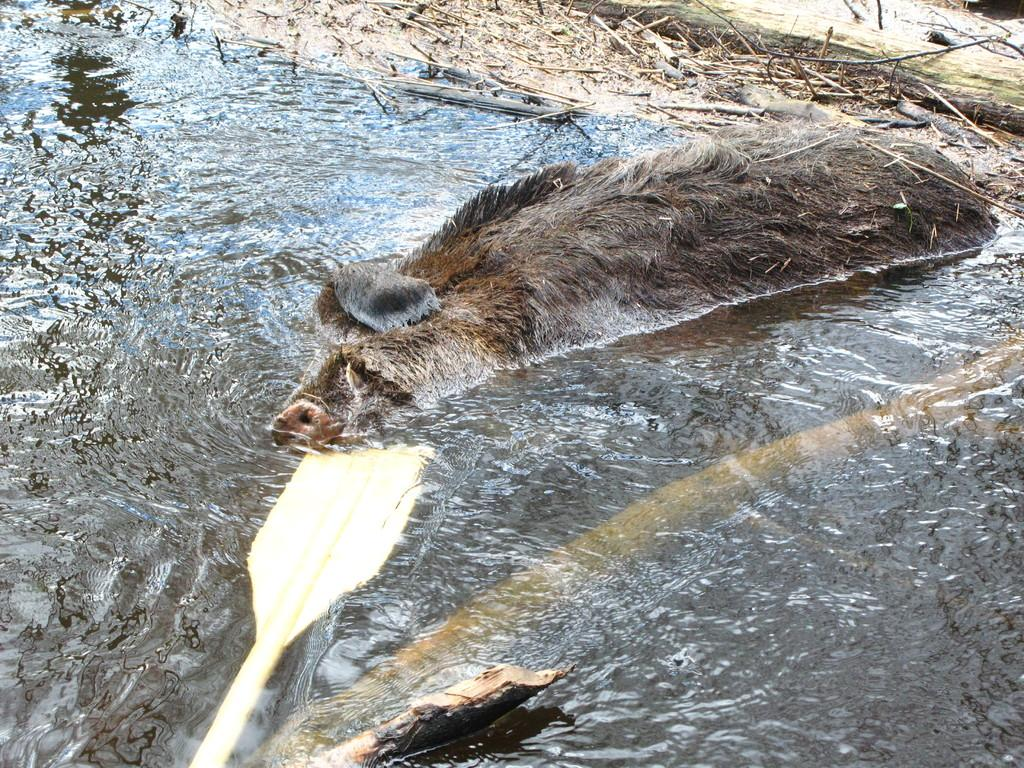What type of animal is present in the image? There is an animal in the image. What is the animal doing in the image? The animal is swimming in the water. What can be seen in the water alongside the animal? There are twigs visible in the image. What type of fruit is the animal holding in its mouth in the image? There is no fruit present in the image, and the animal is not holding anything in its mouth. What type of pest is the animal trying to eliminate in the image? There is no indication of any pests in the image; the animal is simply swimming in the water. 